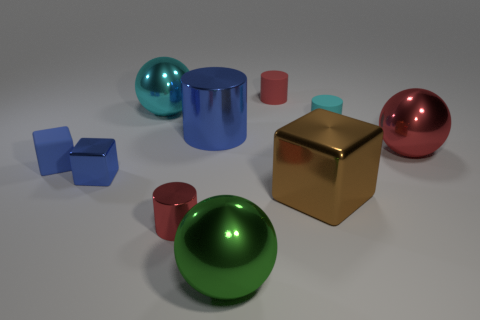Subtract all yellow cylinders. Subtract all brown cubes. How many cylinders are left? 4 Subtract all cylinders. How many objects are left? 6 Add 1 blue rubber cubes. How many blue rubber cubes exist? 2 Subtract 0 gray balls. How many objects are left? 10 Subtract all shiny cylinders. Subtract all big shiny cylinders. How many objects are left? 7 Add 6 blue matte things. How many blue matte things are left? 7 